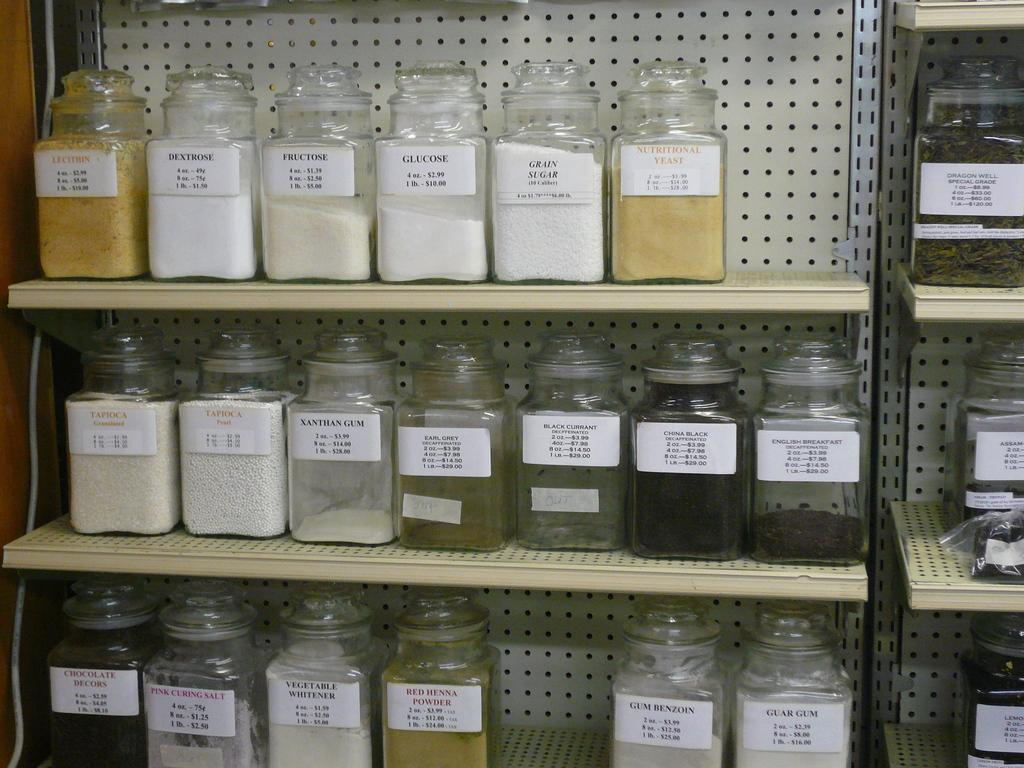What can be seen in the image? There are many jars in the image. How are the jars arranged in the image? The jars are in racks. What type of juice is being squeezed out of the thumb in the image? There is no thumb or juice present in the image; it only features jars in racks. 